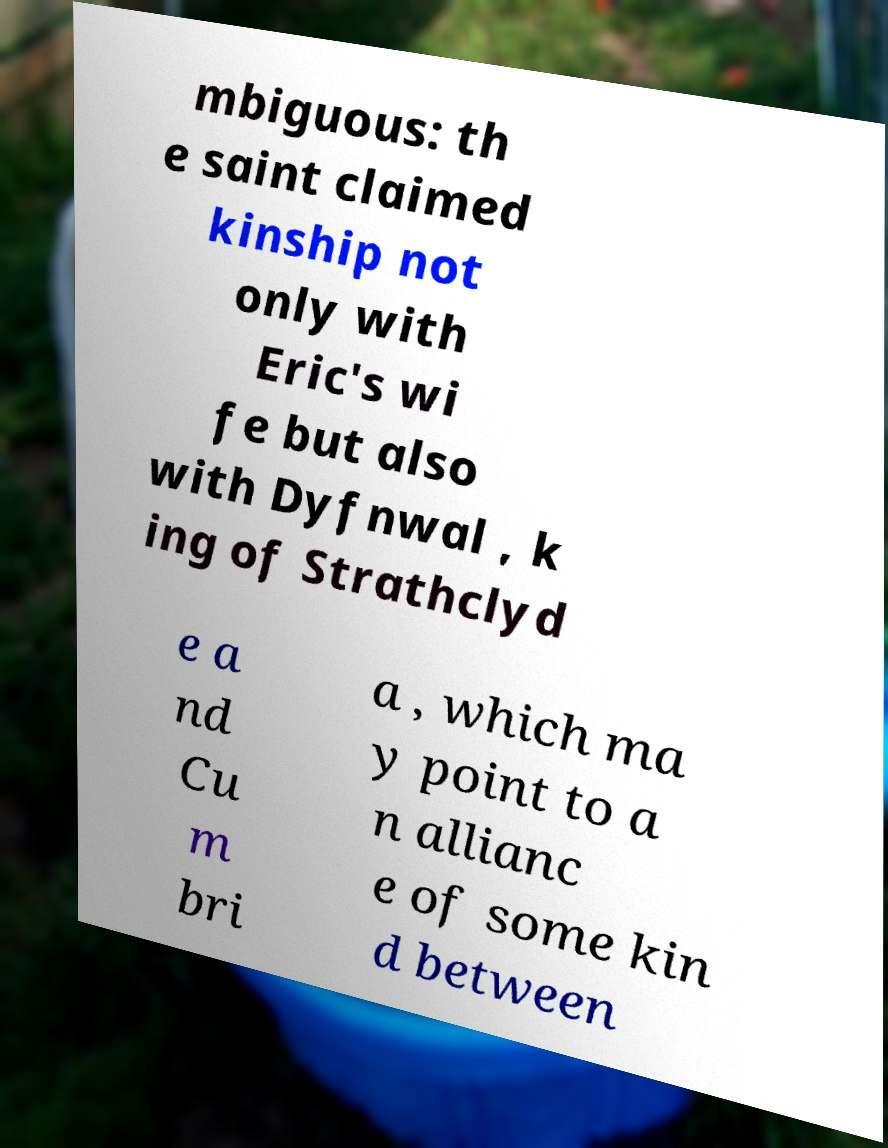Could you extract and type out the text from this image? mbiguous: th e saint claimed kinship not only with Eric's wi fe but also with Dyfnwal , k ing of Strathclyd e a nd Cu m bri a , which ma y point to a n allianc e of some kin d between 